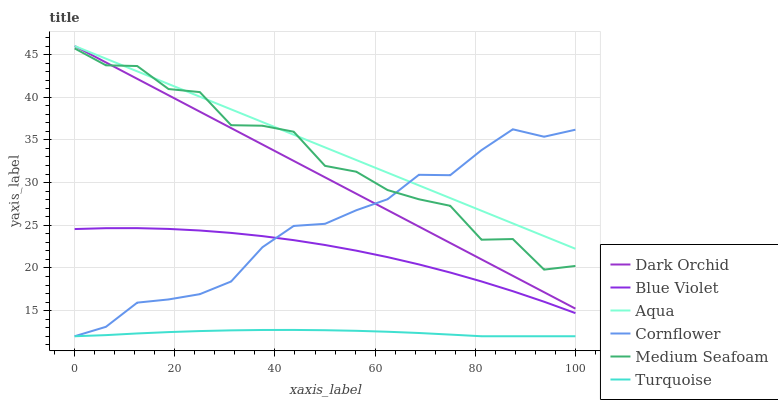Does Turquoise have the minimum area under the curve?
Answer yes or no. Yes. Does Aqua have the maximum area under the curve?
Answer yes or no. Yes. Does Aqua have the minimum area under the curve?
Answer yes or no. No. Does Turquoise have the maximum area under the curve?
Answer yes or no. No. Is Dark Orchid the smoothest?
Answer yes or no. Yes. Is Medium Seafoam the roughest?
Answer yes or no. Yes. Is Turquoise the smoothest?
Answer yes or no. No. Is Turquoise the roughest?
Answer yes or no. No. Does Aqua have the lowest value?
Answer yes or no. No. Does Dark Orchid have the highest value?
Answer yes or no. Yes. Does Turquoise have the highest value?
Answer yes or no. No. Is Turquoise less than Medium Seafoam?
Answer yes or no. Yes. Is Dark Orchid greater than Blue Violet?
Answer yes or no. Yes. Does Medium Seafoam intersect Aqua?
Answer yes or no. Yes. Is Medium Seafoam less than Aqua?
Answer yes or no. No. Is Medium Seafoam greater than Aqua?
Answer yes or no. No. Does Turquoise intersect Medium Seafoam?
Answer yes or no. No. 